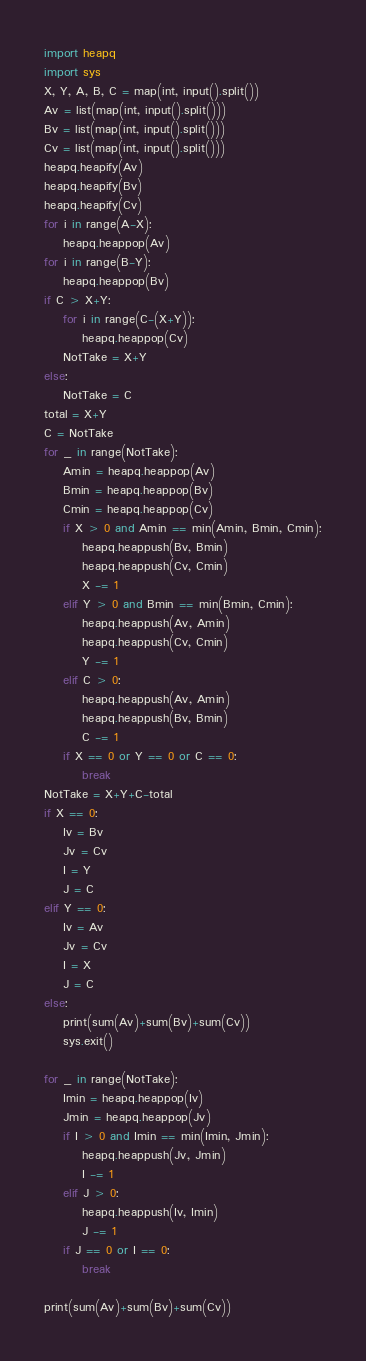<code> <loc_0><loc_0><loc_500><loc_500><_Python_>import heapq
import sys
X, Y, A, B, C = map(int, input().split())
Av = list(map(int, input().split()))
Bv = list(map(int, input().split()))
Cv = list(map(int, input().split()))
heapq.heapify(Av)
heapq.heapify(Bv)
heapq.heapify(Cv)
for i in range(A-X):
    heapq.heappop(Av)
for i in range(B-Y):
    heapq.heappop(Bv)
if C > X+Y:
    for i in range(C-(X+Y)):
        heapq.heappop(Cv)
    NotTake = X+Y
else:
    NotTake = C
total = X+Y
C = NotTake
for _ in range(NotTake):
    Amin = heapq.heappop(Av)
    Bmin = heapq.heappop(Bv)
    Cmin = heapq.heappop(Cv)
    if X > 0 and Amin == min(Amin, Bmin, Cmin):
        heapq.heappush(Bv, Bmin)
        heapq.heappush(Cv, Cmin)
        X -= 1
    elif Y > 0 and Bmin == min(Bmin, Cmin):
        heapq.heappush(Av, Amin)
        heapq.heappush(Cv, Cmin)
        Y -= 1
    elif C > 0:
        heapq.heappush(Av, Amin)
        heapq.heappush(Bv, Bmin)
        C -= 1
    if X == 0 or Y == 0 or C == 0:
        break
NotTake = X+Y+C-total
if X == 0:
    Iv = Bv
    Jv = Cv
    I = Y
    J = C
elif Y == 0:
    Iv = Av
    Jv = Cv
    I = X
    J = C
else:
    print(sum(Av)+sum(Bv)+sum(Cv))
    sys.exit()

for _ in range(NotTake):
    Imin = heapq.heappop(Iv)
    Jmin = heapq.heappop(Jv)
    if I > 0 and Imin == min(Imin, Jmin):
        heapq.heappush(Jv, Jmin)
        I -= 1
    elif J > 0:
        heapq.heappush(Iv, Imin)
        J -= 1
    if J == 0 or I == 0:
        break

print(sum(Av)+sum(Bv)+sum(Cv))
</code> 